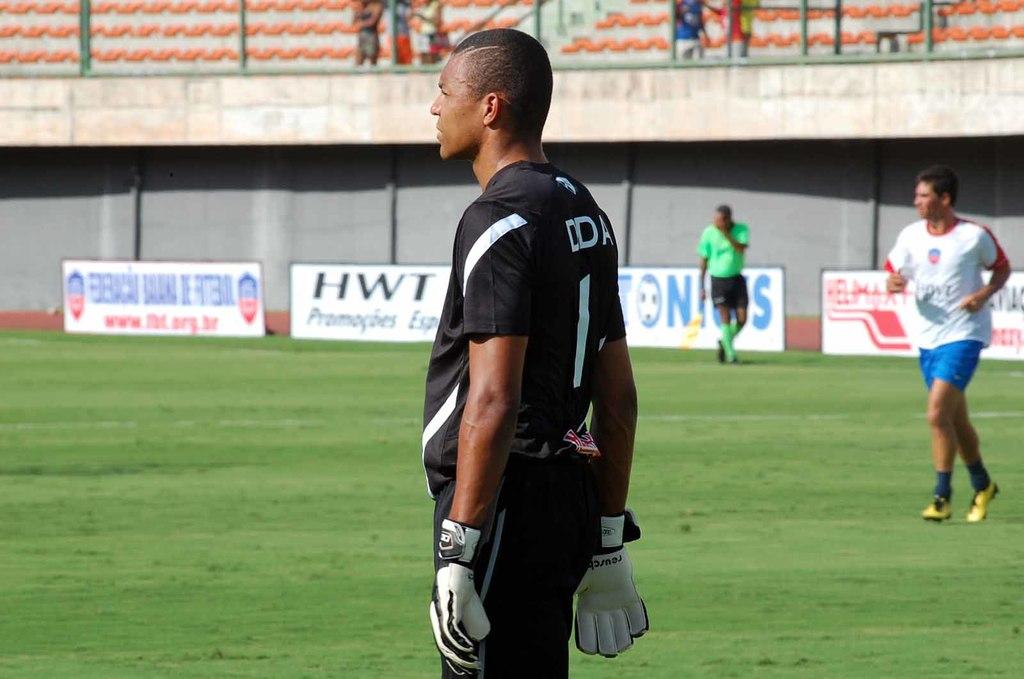What initials are being advertised boldly on the white and black sign?
Offer a terse response. Hwt. What is this player's number?
Keep it short and to the point. 1. 